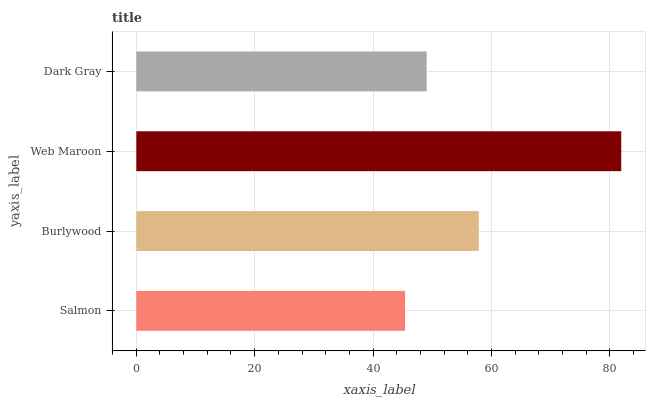Is Salmon the minimum?
Answer yes or no. Yes. Is Web Maroon the maximum?
Answer yes or no. Yes. Is Burlywood the minimum?
Answer yes or no. No. Is Burlywood the maximum?
Answer yes or no. No. Is Burlywood greater than Salmon?
Answer yes or no. Yes. Is Salmon less than Burlywood?
Answer yes or no. Yes. Is Salmon greater than Burlywood?
Answer yes or no. No. Is Burlywood less than Salmon?
Answer yes or no. No. Is Burlywood the high median?
Answer yes or no. Yes. Is Dark Gray the low median?
Answer yes or no. Yes. Is Web Maroon the high median?
Answer yes or no. No. Is Salmon the low median?
Answer yes or no. No. 